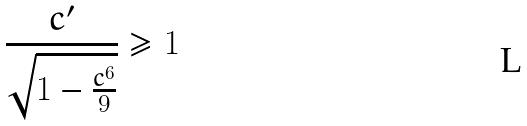Convert formula to latex. <formula><loc_0><loc_0><loc_500><loc_500>\frac { c ^ { \prime } } { \sqrt { 1 - \frac { c ^ { 6 } } { 9 } } } \geq 1</formula> 